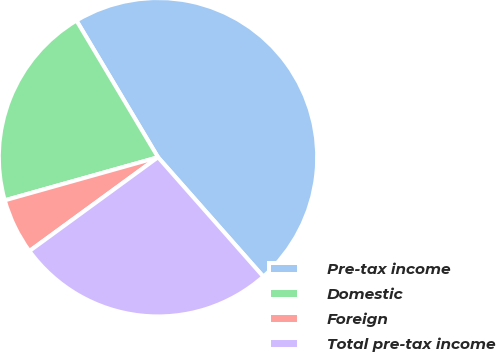Convert chart. <chart><loc_0><loc_0><loc_500><loc_500><pie_chart><fcel>Pre-tax income<fcel>Domestic<fcel>Foreign<fcel>Total pre-tax income<nl><fcel>47.05%<fcel>20.8%<fcel>5.67%<fcel>26.47%<nl></chart> 